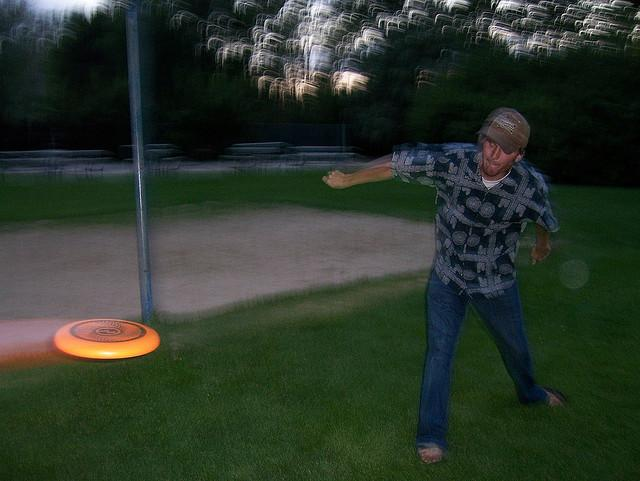In which type space does this man spin his frisbee?

Choices:
A) beach
B) jail
C) urban
D) park park 